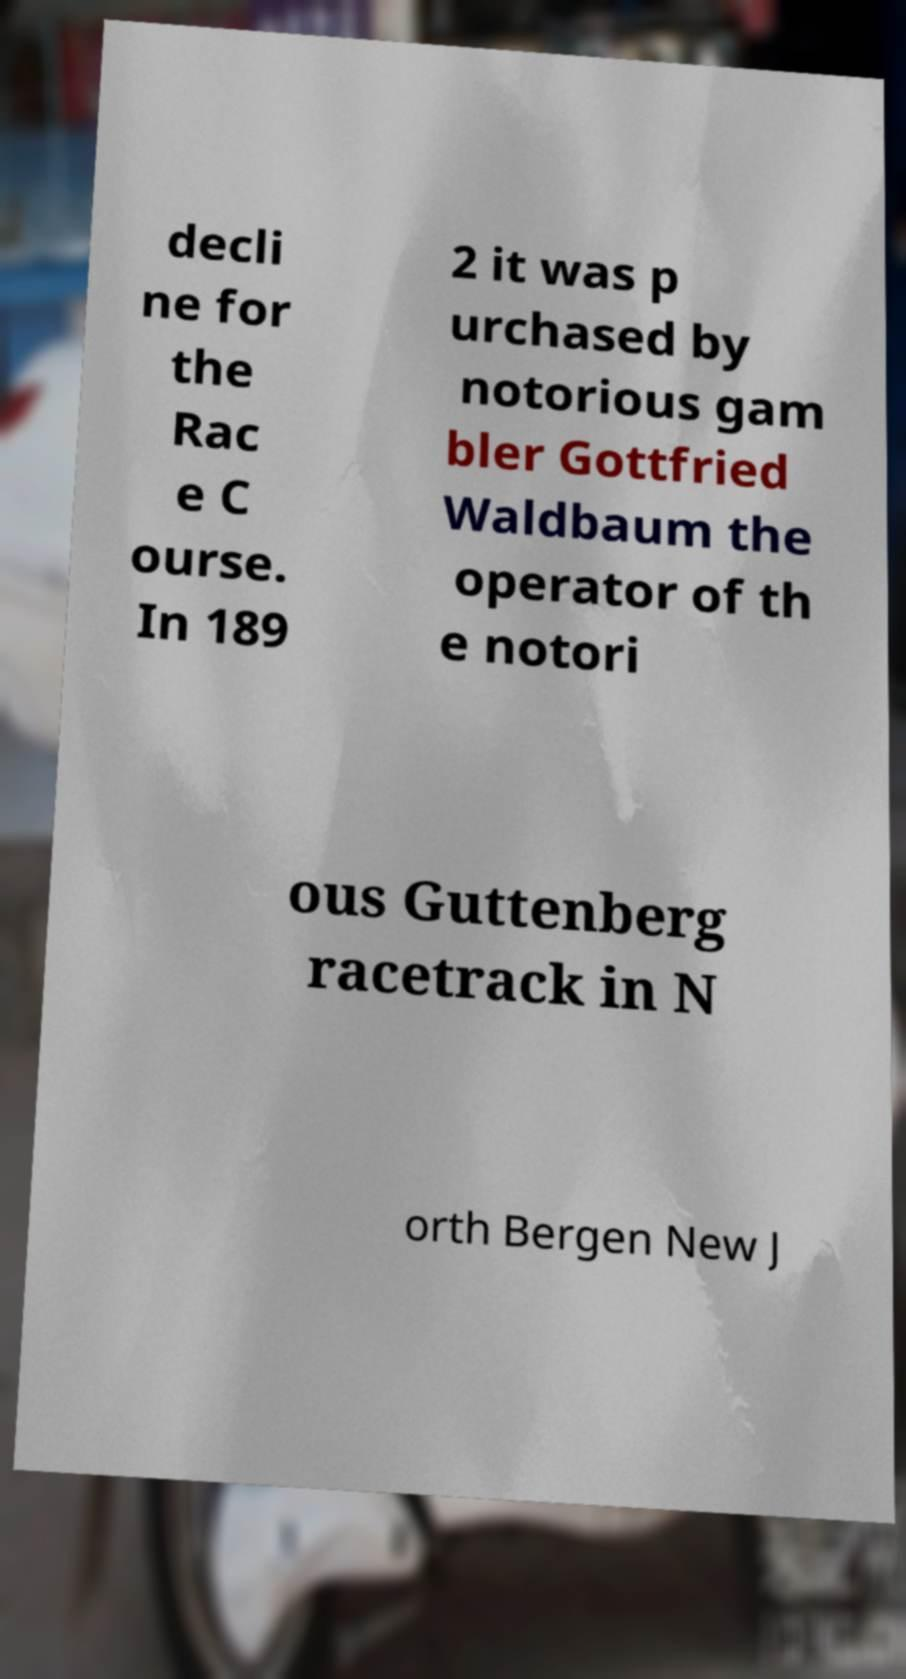Please identify and transcribe the text found in this image. decli ne for the Rac e C ourse. In 189 2 it was p urchased by notorious gam bler Gottfried Waldbaum the operator of th e notori ous Guttenberg racetrack in N orth Bergen New J 